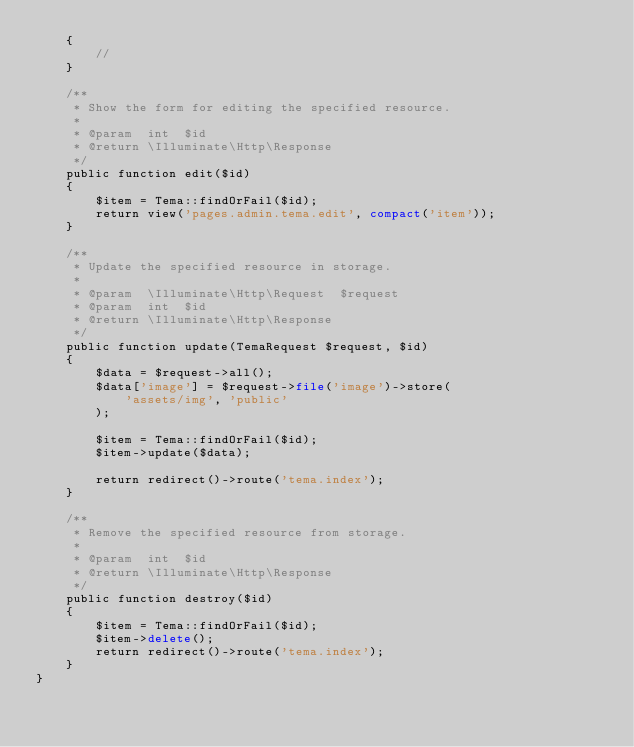Convert code to text. <code><loc_0><loc_0><loc_500><loc_500><_PHP_>    {
        //
    }

    /**
     * Show the form for editing the specified resource.
     *
     * @param  int  $id
     * @return \Illuminate\Http\Response
     */
    public function edit($id)
    {
        $item = Tema::findOrFail($id);
        return view('pages.admin.tema.edit', compact('item'));
    }

    /**
     * Update the specified resource in storage.
     *
     * @param  \Illuminate\Http\Request  $request
     * @param  int  $id
     * @return \Illuminate\Http\Response
     */
    public function update(TemaRequest $request, $id)
    {
        $data = $request->all();
        $data['image'] = $request->file('image')->store(
            'assets/img', 'public'
        );

        $item = Tema::findOrFail($id);
        $item->update($data);

        return redirect()->route('tema.index');
    }

    /**
     * Remove the specified resource from storage.
     *
     * @param  int  $id
     * @return \Illuminate\Http\Response
     */
    public function destroy($id)
    {
        $item = Tema::findOrFail($id);
        $item->delete();
        return redirect()->route('tema.index');
    }
}
</code> 